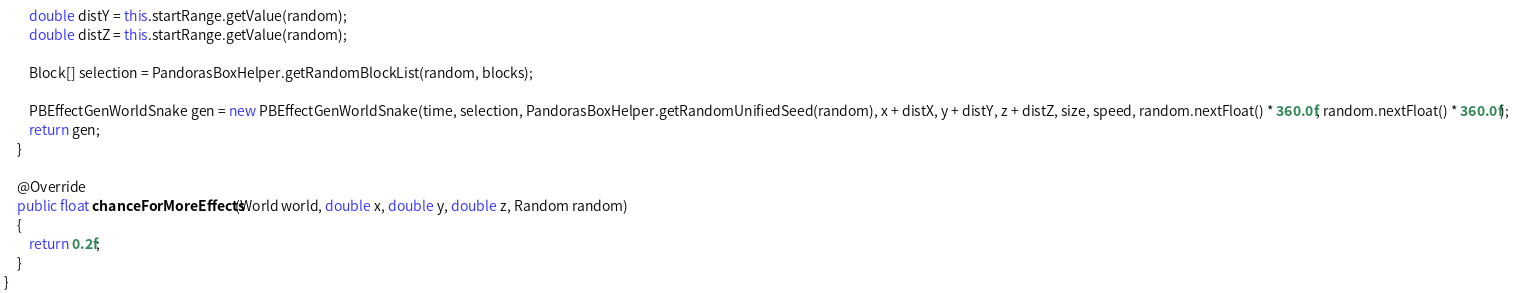Convert code to text. <code><loc_0><loc_0><loc_500><loc_500><_Java_>        double distY = this.startRange.getValue(random);
        double distZ = this.startRange.getValue(random);

        Block[] selection = PandorasBoxHelper.getRandomBlockList(random, blocks);

        PBEffectGenWorldSnake gen = new PBEffectGenWorldSnake(time, selection, PandorasBoxHelper.getRandomUnifiedSeed(random), x + distX, y + distY, z + distZ, size, speed, random.nextFloat() * 360.0f, random.nextFloat() * 360.0f);
        return gen;
    }

    @Override
    public float chanceForMoreEffects(World world, double x, double y, double z, Random random)
    {
        return 0.2f;
    }
}
</code> 